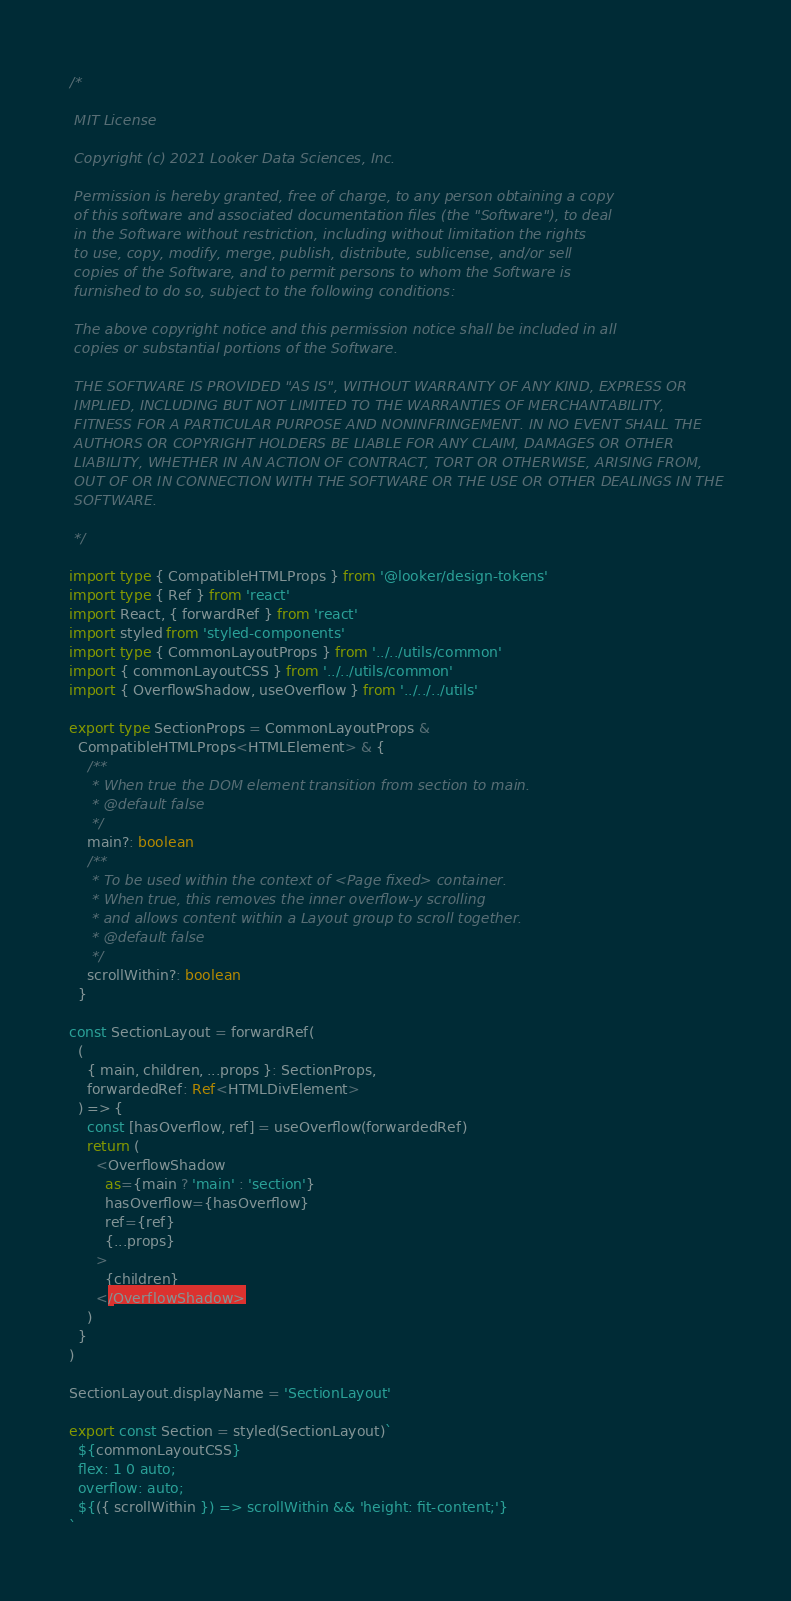<code> <loc_0><loc_0><loc_500><loc_500><_TypeScript_>/*

 MIT License

 Copyright (c) 2021 Looker Data Sciences, Inc.

 Permission is hereby granted, free of charge, to any person obtaining a copy
 of this software and associated documentation files (the "Software"), to deal
 in the Software without restriction, including without limitation the rights
 to use, copy, modify, merge, publish, distribute, sublicense, and/or sell
 copies of the Software, and to permit persons to whom the Software is
 furnished to do so, subject to the following conditions:

 The above copyright notice and this permission notice shall be included in all
 copies or substantial portions of the Software.

 THE SOFTWARE IS PROVIDED "AS IS", WITHOUT WARRANTY OF ANY KIND, EXPRESS OR
 IMPLIED, INCLUDING BUT NOT LIMITED TO THE WARRANTIES OF MERCHANTABILITY,
 FITNESS FOR A PARTICULAR PURPOSE AND NONINFRINGEMENT. IN NO EVENT SHALL THE
 AUTHORS OR COPYRIGHT HOLDERS BE LIABLE FOR ANY CLAIM, DAMAGES OR OTHER
 LIABILITY, WHETHER IN AN ACTION OF CONTRACT, TORT OR OTHERWISE, ARISING FROM,
 OUT OF OR IN CONNECTION WITH THE SOFTWARE OR THE USE OR OTHER DEALINGS IN THE
 SOFTWARE.

 */

import type { CompatibleHTMLProps } from '@looker/design-tokens'
import type { Ref } from 'react'
import React, { forwardRef } from 'react'
import styled from 'styled-components'
import type { CommonLayoutProps } from '../../utils/common'
import { commonLayoutCSS } from '../../utils/common'
import { OverflowShadow, useOverflow } from '../../../utils'

export type SectionProps = CommonLayoutProps &
  CompatibleHTMLProps<HTMLElement> & {
    /**
     * When true the DOM element transition from section to main.
     * @default false
     */
    main?: boolean
    /**
     * To be used within the context of <Page fixed> container.
     * When true, this removes the inner overflow-y scrolling
     * and allows content within a Layout group to scroll together.
     * @default false
     */
    scrollWithin?: boolean
  }

const SectionLayout = forwardRef(
  (
    { main, children, ...props }: SectionProps,
    forwardedRef: Ref<HTMLDivElement>
  ) => {
    const [hasOverflow, ref] = useOverflow(forwardedRef)
    return (
      <OverflowShadow
        as={main ? 'main' : 'section'}
        hasOverflow={hasOverflow}
        ref={ref}
        {...props}
      >
        {children}
      </OverflowShadow>
    )
  }
)

SectionLayout.displayName = 'SectionLayout'

export const Section = styled(SectionLayout)`
  ${commonLayoutCSS}
  flex: 1 0 auto;
  overflow: auto;
  ${({ scrollWithin }) => scrollWithin && 'height: fit-content;'}
`
</code> 